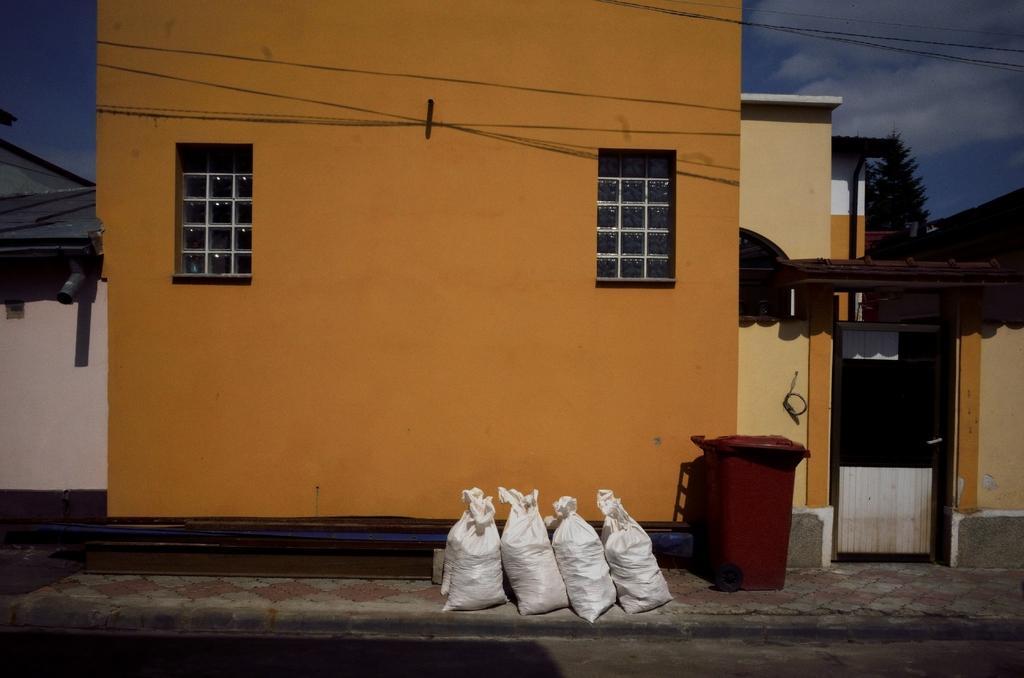Could you give a brief overview of what you see in this image? In this image I can see few white colour things, a red colour container, few buildings, windows, a tree, few wires, clouds and the sky. 